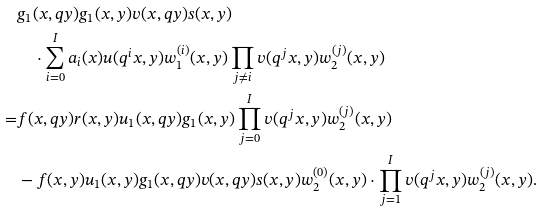Convert formula to latex. <formula><loc_0><loc_0><loc_500><loc_500>& g _ { 1 } ( x , q y ) g _ { 1 } ( x , y ) v ( x , q y ) s ( x , y ) \\ & \quad \cdot \sum _ { i = 0 } ^ { I } a _ { i } ( x ) u ( q ^ { i } x , y ) w _ { 1 } ^ { ( i ) } ( x , y ) \prod _ { j \not = i } v ( q ^ { j } x , y ) w _ { 2 } ^ { ( j ) } ( x , y ) \\ = & f ( x , q y ) r ( x , y ) u _ { 1 } ( x , q y ) g _ { 1 } ( x , y ) \prod _ { j = 0 } ^ { I } v ( q ^ { j } x , y ) w _ { 2 } ^ { ( j ) } ( x , y ) \\ & - f ( x , y ) u _ { 1 } ( x , y ) g _ { 1 } ( x , q y ) v ( x , q y ) s ( x , y ) w _ { 2 } ^ { ( 0 ) } ( x , y ) \cdot \prod _ { j = 1 } ^ { I } v ( q ^ { j } x , y ) w _ { 2 } ^ { ( j ) } ( x , y ) .</formula> 